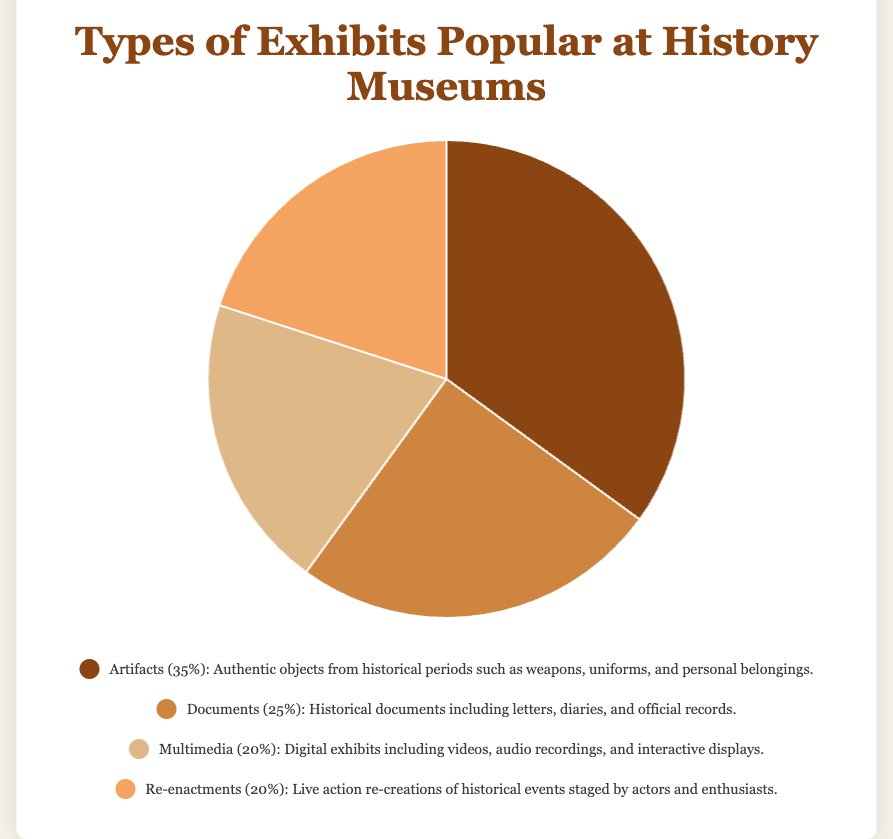What is the most popular type of exhibit at history museums? The chart shows four types of exhibits and their respective percentages. Artifacts has the highest value at 35%.
Answer: Artifacts Among the exhibits, which two types have an equal percentage? The pie chart shows that both Multimedia and Re-enactments have the same percentage of 20% each.
Answer: Multimedia and Re-enactments How much more popular are Artifacts compared to Documents in percentage points? The percentage for Artifacts is 35% and for Documents is 25%. The difference between them is 35% - 25% = 10%.
Answer: 10% What percentage of exhibits are either Multimedia or Re-enactments? The percentages for Multimedia and Re-enactments are both 20%. Adding them gives 20% + 20% = 40%.
Answer: 40% Which exhibit type is represented by the brown color in the pie chart? The brown color represents the section with 35%, which is labeled as Artifacts.
Answer: Artifacts What is the combined percentage for Artifacts and Documents exhibits? Artifacts are 35% and Documents are 25%. Adding them results in 35% + 25% = 60%.
Answer: 60% Which exhibit type is less popular than Documents but more popular than Re-enactments? Documents have 25%, Re-enactments have 20%, and the only type that meets the criteria is Multimedia with 20%.
Answer: None (Documents are more popular than the others except Artifacts) If Artifacts and Re-enactments were combined into a single category, what would their total percentage be? The percentages for Artifacts and Re-enactments are 35% and 20%, respectively. Adding them together results in 35% + 20% = 55%.
Answer: 55% What percentage difference is there between the most popular and the least popular type of exhibit? The most popular type (Artifacts) is 35% and the least popular types (Multimedia/Re-enactments) are 20%. The difference is 35% - 20% = 15%.
Answer: 15% Which exhibit types fall below the average percentage of all types? The average percentage is calculated by (35% + 25% + 20% + 20%) / 4 = 25%. Both Multimedia at 20% and Re-enactments at 20% fall below the average.
Answer: Multimedia and Re-enactments 